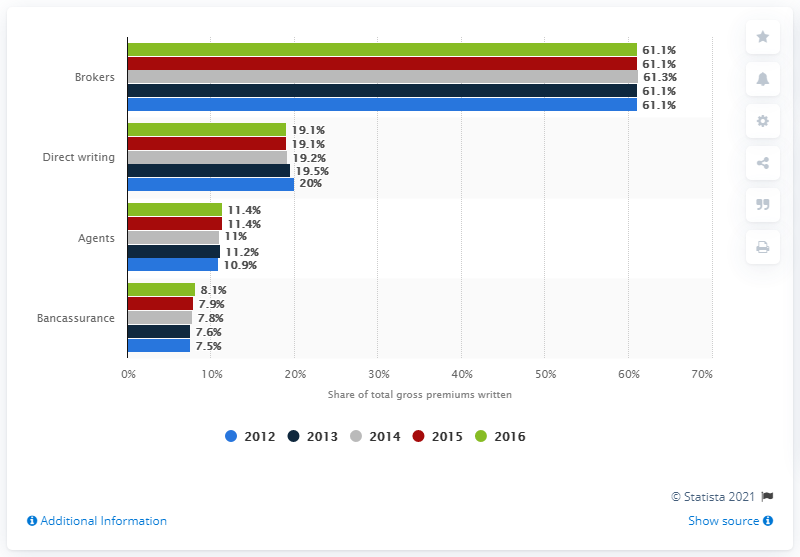Mention a couple of crucial points in this snapshot. In 2016, brokers wrote 61.1% of the total non-life premiums written in Belgium. 